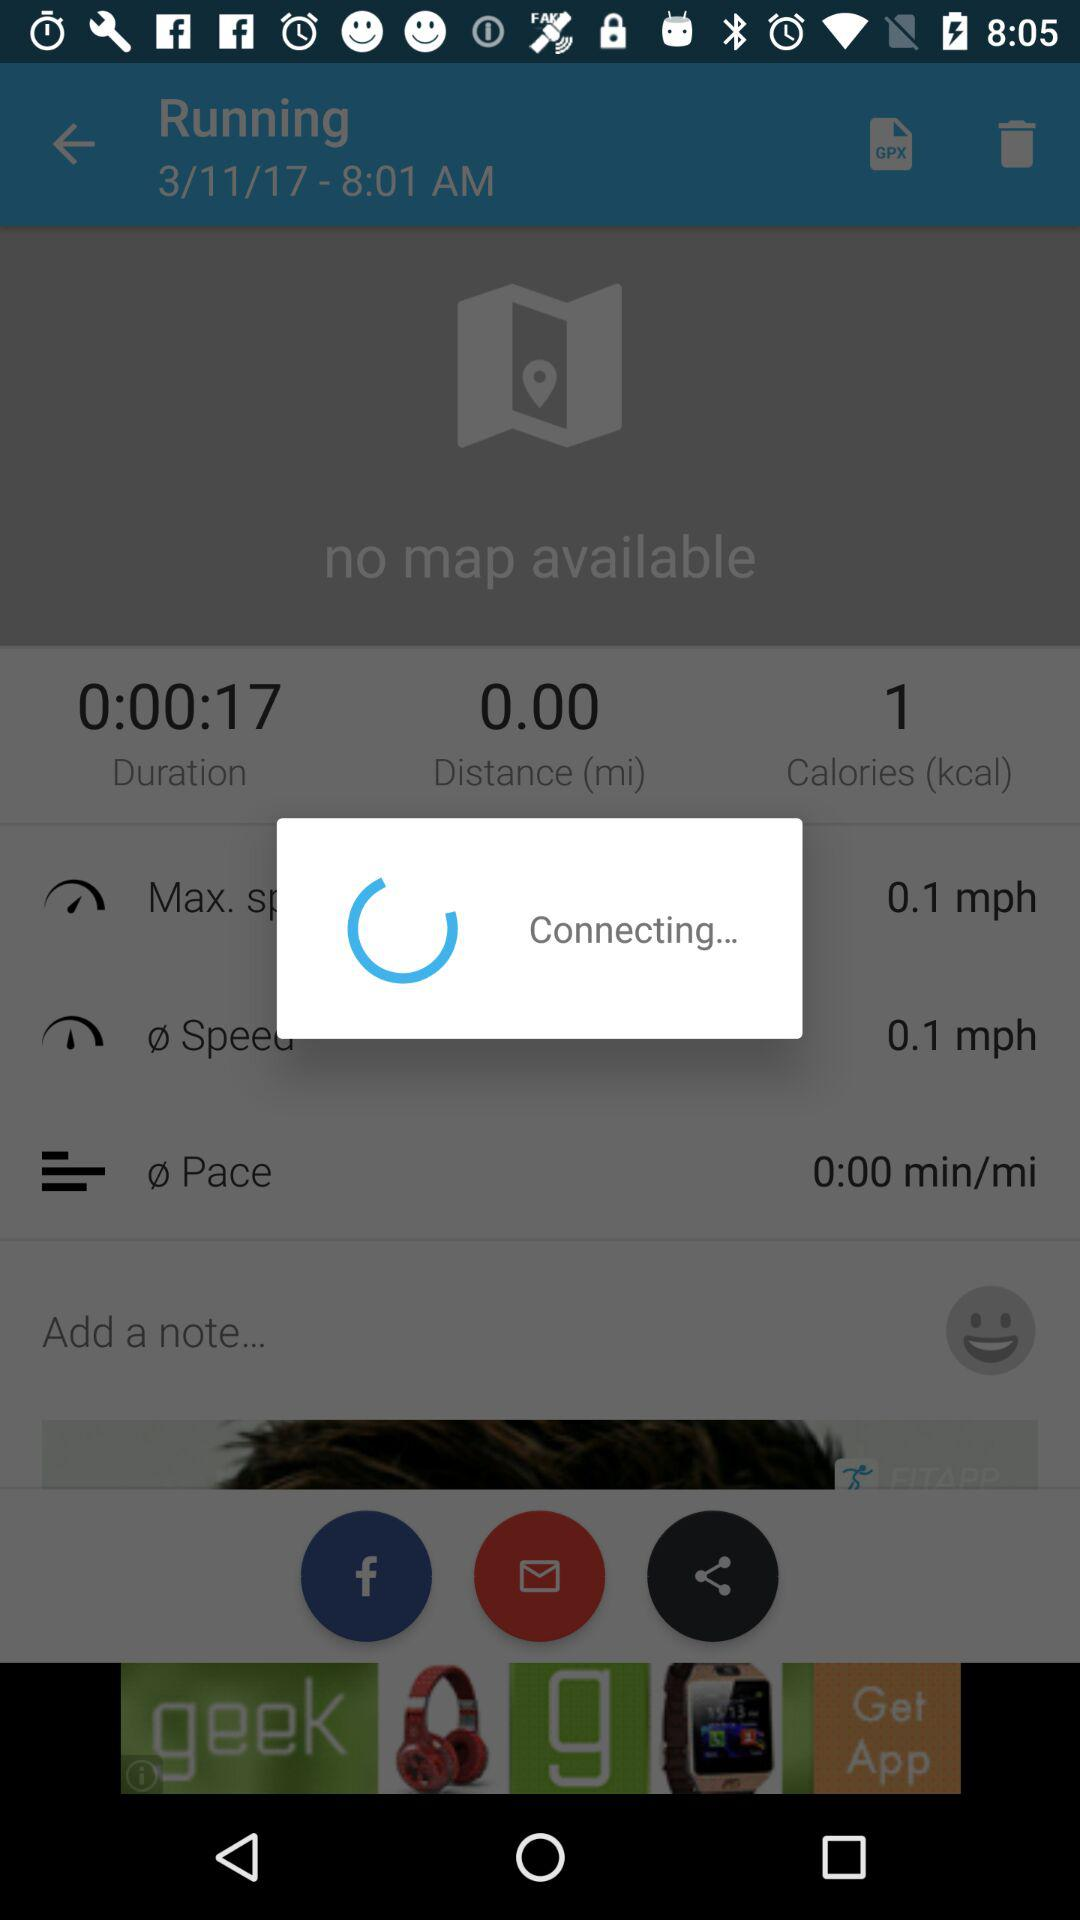To where is the user running?
When the provided information is insufficient, respond with <no answer>. <no answer> 